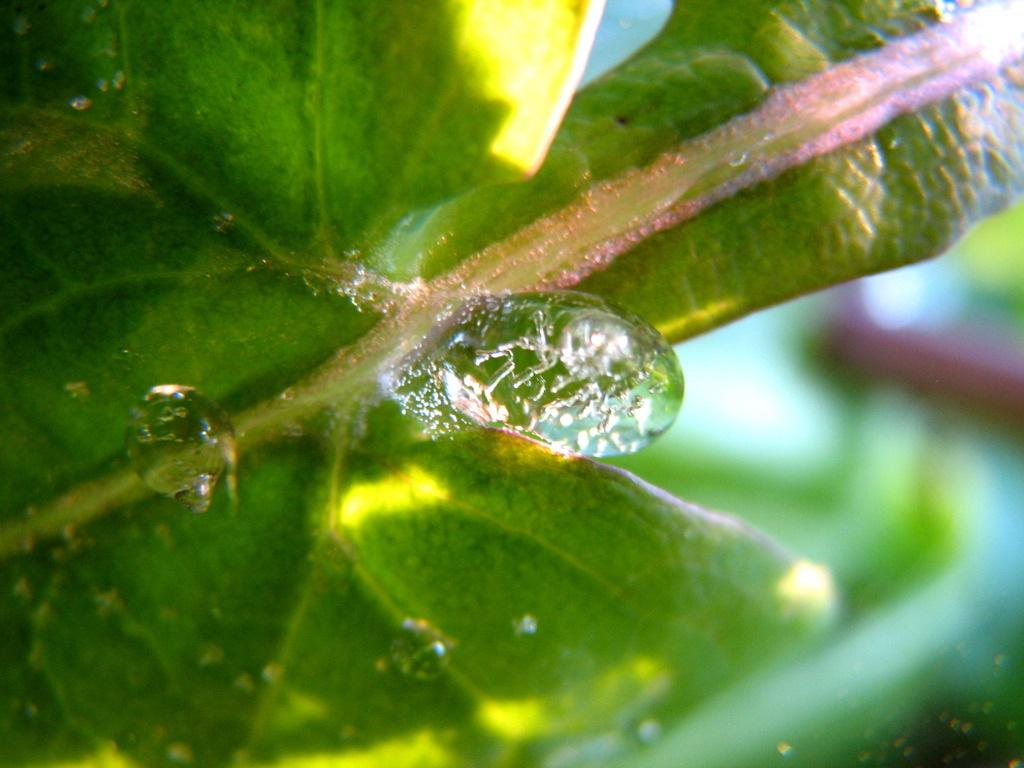What is the primary element visible in the image? There is water in the image. What type of plant material can be seen in the image? There is a leaf in the image. How would you describe the background of the image? The background of the image is blurred. What type of decision can be seen being made by the creature in the image? There is no creature present in the image, so no decision can be observed. 